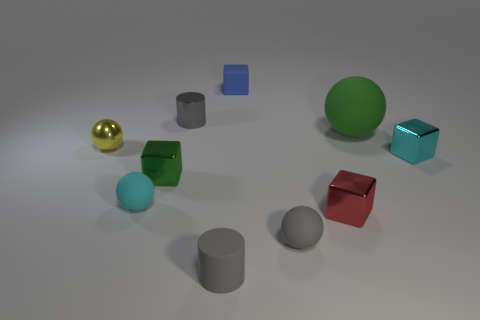Are there any other things that are the same size as the green ball?
Make the answer very short. No. There is a tiny cyan thing to the left of the tiny metal object to the right of the green matte sphere; what shape is it?
Offer a very short reply. Sphere. There is a gray cylinder that is behind the green object on the right side of the red shiny cube; how big is it?
Provide a short and direct response. Small. There is a rubber sphere behind the small green metallic block; what is its color?
Give a very brief answer. Green. The green ball that is the same material as the tiny cyan ball is what size?
Your answer should be very brief. Large. What number of cyan things have the same shape as the tiny yellow metal thing?
Offer a very short reply. 1. What is the material of the yellow thing that is the same size as the cyan cube?
Ensure brevity in your answer.  Metal. Is there a large brown cylinder that has the same material as the tiny red thing?
Your answer should be very brief. No. What is the color of the tiny object that is behind the tiny yellow metallic sphere and to the right of the gray shiny cylinder?
Ensure brevity in your answer.  Blue. What number of other objects are the same color as the tiny metal cylinder?
Ensure brevity in your answer.  2. 